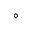Convert formula to latex. <formula><loc_0><loc_0><loc_500><loc_500>^ { \circ }</formula> 